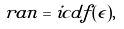<formula> <loc_0><loc_0><loc_500><loc_500>r a n = i c d f ( \epsilon ) ,</formula> 